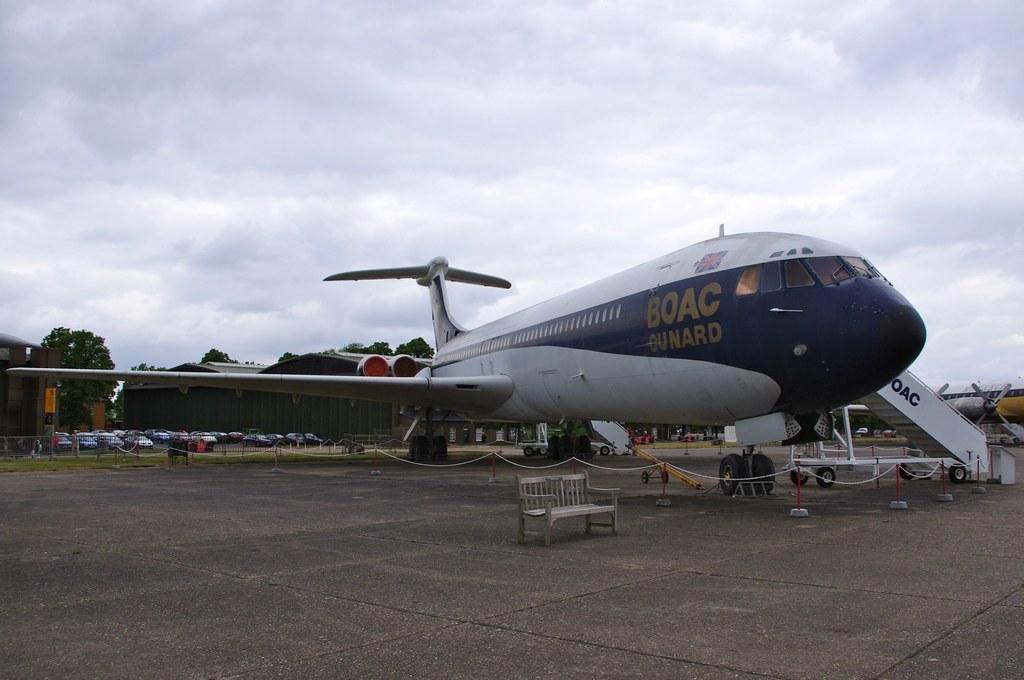Please provide a concise description of this image. In this image I can see a airplane and in the background I can see number of vehicles, buildings and few trees. I can also see cloudy sky. 